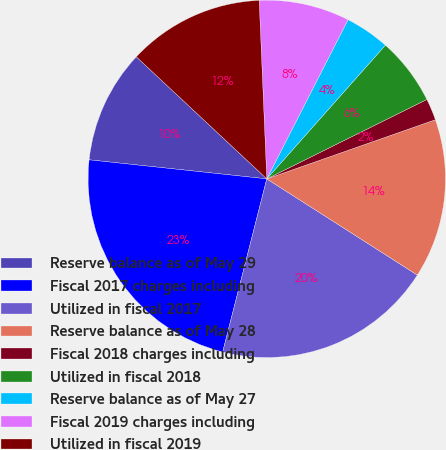Convert chart to OTSL. <chart><loc_0><loc_0><loc_500><loc_500><pie_chart><fcel>Reserve balance as of May 29<fcel>Fiscal 2017 charges including<fcel>Utilized in fiscal 2017<fcel>Reserve balance as of May 28<fcel>Fiscal 2018 charges including<fcel>Utilized in fiscal 2018<fcel>Reserve balance as of May 27<fcel>Fiscal 2019 charges including<fcel>Utilized in fiscal 2019<nl><fcel>10.27%<fcel>22.73%<fcel>19.92%<fcel>14.42%<fcel>1.96%<fcel>6.12%<fcel>4.04%<fcel>8.19%<fcel>12.35%<nl></chart> 